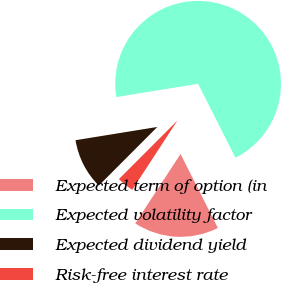Convert chart to OTSL. <chart><loc_0><loc_0><loc_500><loc_500><pie_chart><fcel>Expected term of option (in<fcel>Expected volatility factor<fcel>Expected dividend yield<fcel>Risk-free interest rate<nl><fcel>16.64%<fcel>70.11%<fcel>9.96%<fcel>3.29%<nl></chart> 